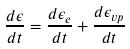<formula> <loc_0><loc_0><loc_500><loc_500>\frac { d \epsilon } { d t } = \frac { d \epsilon _ { e } } { d t } + \frac { d \epsilon _ { v p } } { d t }</formula> 